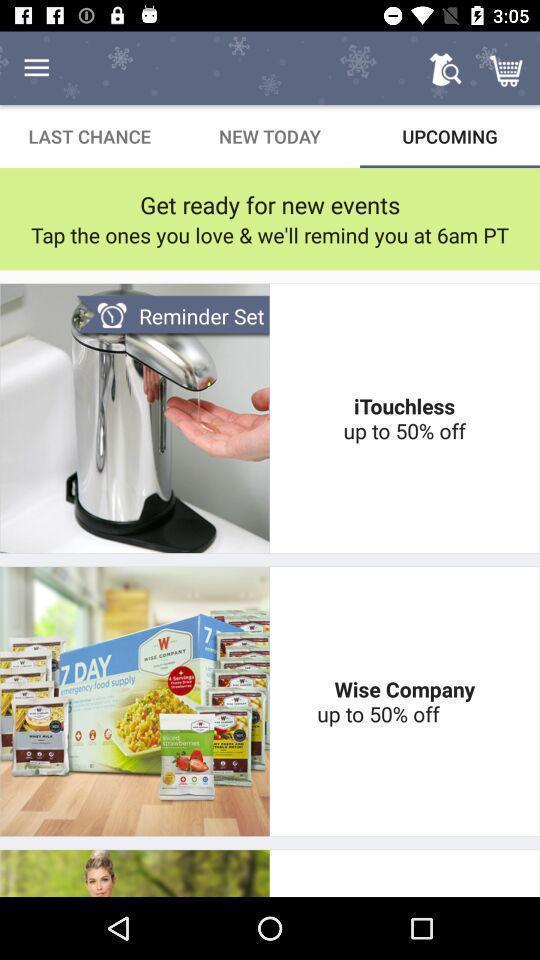Give me a narrative description of this picture. Various buying discount offers to remind you on shopping app. 